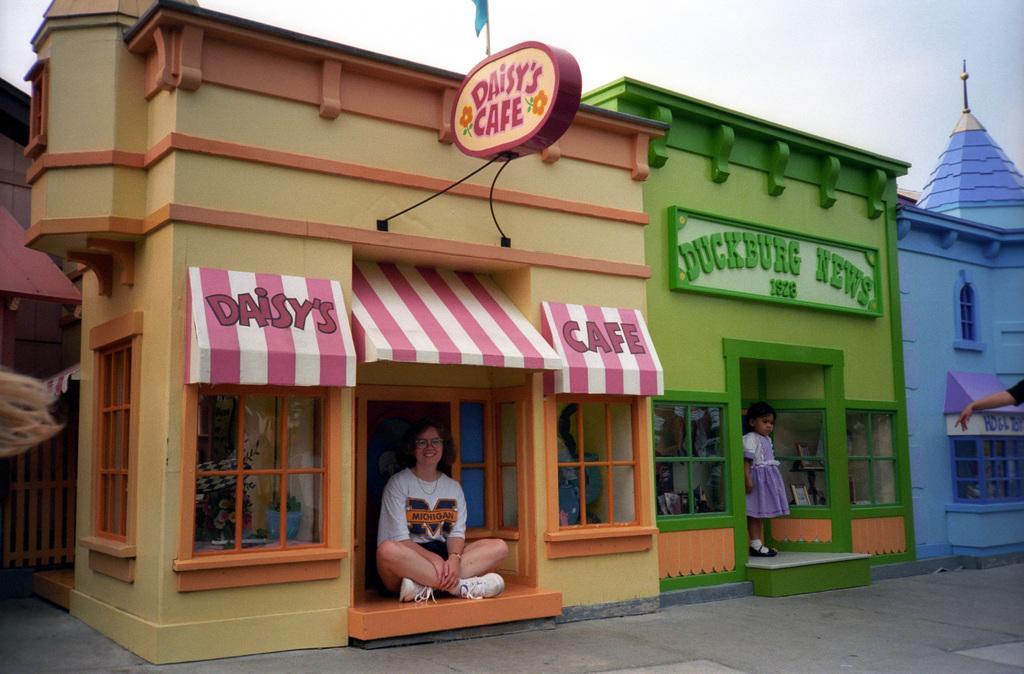In one or two sentences, can you explain what this image depicts? In this image there is a woman and a girl posing in front of miniature homes. 